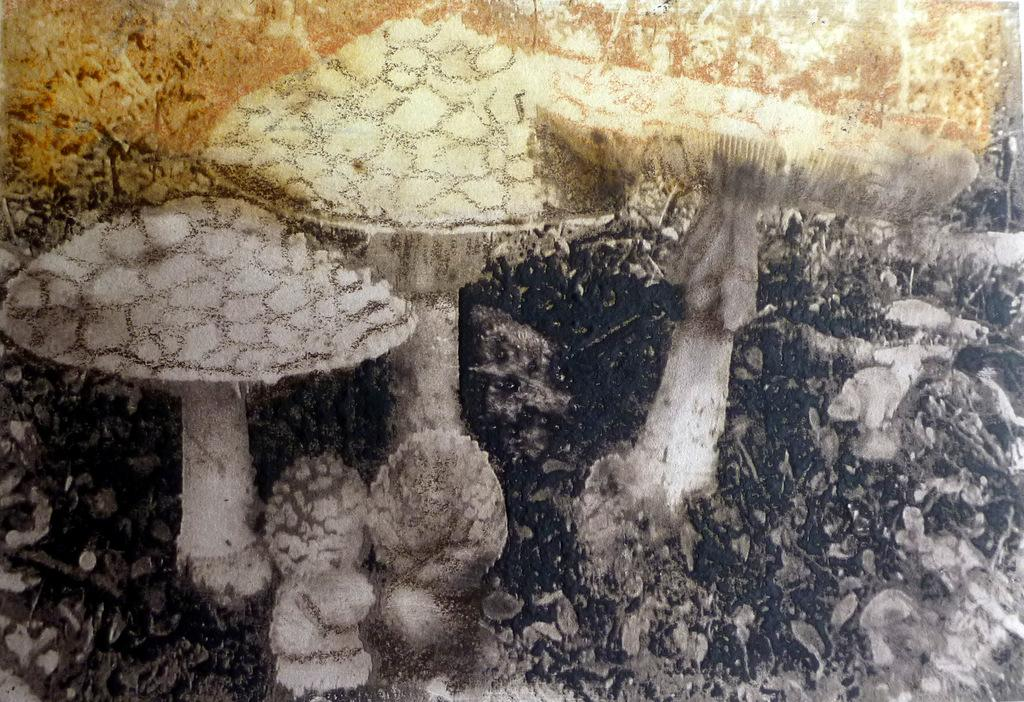What type of vegetation is in the foreground of the image? There are mushrooms in the foreground of the image. Where is the library located in the image? There is no library present in the image; it features mushrooms in the foreground. What type of vegetable is being used to make yam in the image? There is no yam or any cooking activity present in the image. 